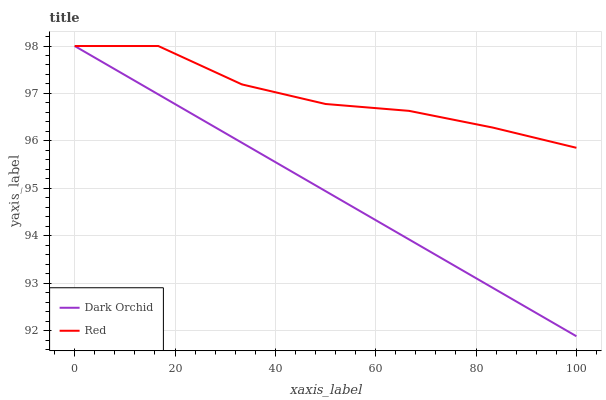Does Dark Orchid have the minimum area under the curve?
Answer yes or no. Yes. Does Red have the maximum area under the curve?
Answer yes or no. Yes. Does Dark Orchid have the maximum area under the curve?
Answer yes or no. No. Is Dark Orchid the smoothest?
Answer yes or no. Yes. Is Red the roughest?
Answer yes or no. Yes. Is Dark Orchid the roughest?
Answer yes or no. No. Does Dark Orchid have the lowest value?
Answer yes or no. Yes. Does Dark Orchid have the highest value?
Answer yes or no. Yes. Does Red intersect Dark Orchid?
Answer yes or no. Yes. Is Red less than Dark Orchid?
Answer yes or no. No. Is Red greater than Dark Orchid?
Answer yes or no. No. 